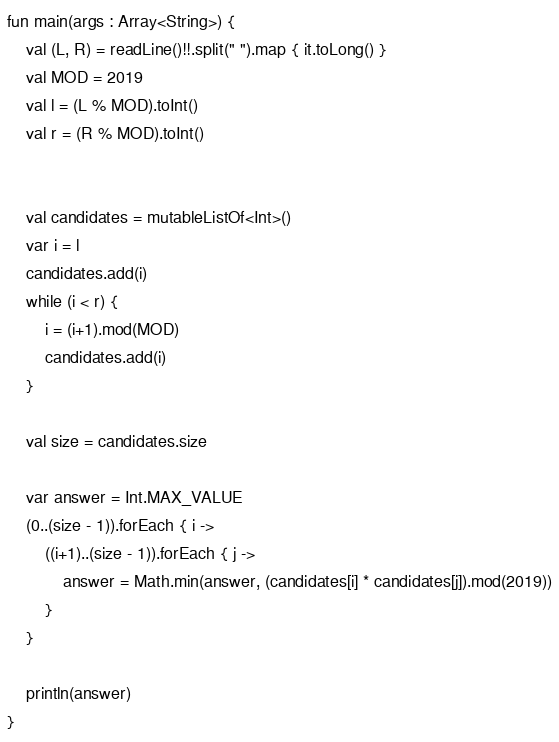Convert code to text. <code><loc_0><loc_0><loc_500><loc_500><_Kotlin_>fun main(args : Array<String>) {
    val (L, R) = readLine()!!.split(" ").map { it.toLong() }
    val MOD = 2019
    val l = (L % MOD).toInt()
    val r = (R % MOD).toInt()


    val candidates = mutableListOf<Int>()
    var i = l
    candidates.add(i)
    while (i < r) {
        i = (i+1).mod(MOD)
        candidates.add(i)
    }

    val size = candidates.size

    var answer = Int.MAX_VALUE
    (0..(size - 1)).forEach { i ->
        ((i+1)..(size - 1)).forEach { j ->
            answer = Math.min(answer, (candidates[i] * candidates[j]).mod(2019))
        }
    }

    println(answer)
}</code> 